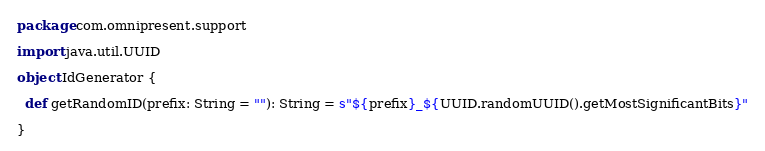Convert code to text. <code><loc_0><loc_0><loc_500><loc_500><_Scala_>package com.omnipresent.support

import java.util.UUID

object IdGenerator {

  def getRandomID(prefix: String = ""): String = s"${prefix}_${UUID.randomUUID().getMostSignificantBits}"

}
</code> 